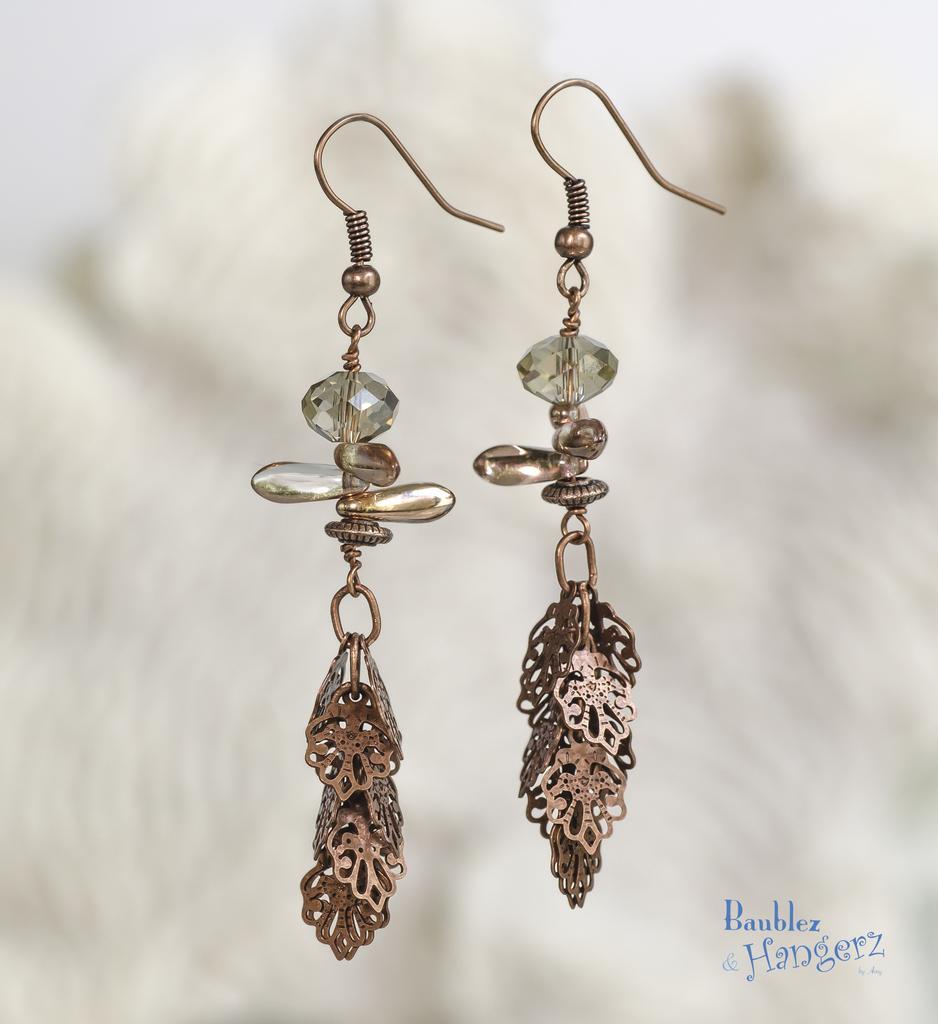Can you describe this image briefly? In this image there is a pair of earrings, and there is blur background and a watermark on the image. 